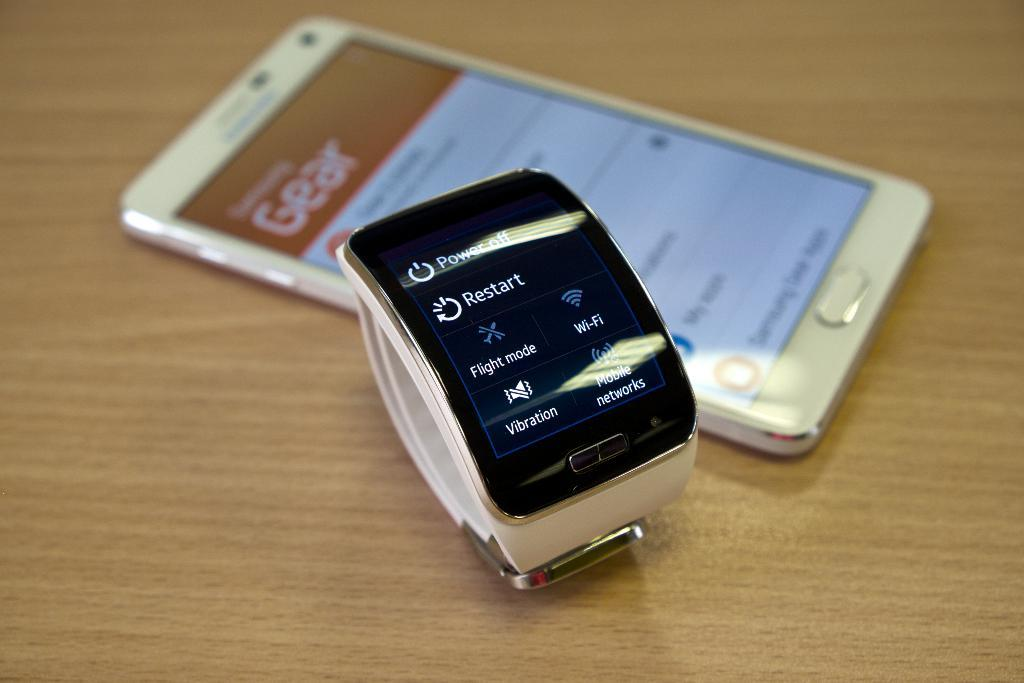<image>
Present a compact description of the photo's key features. A smart watch lying next to a phone shows mobile networks and the WIFI status. 